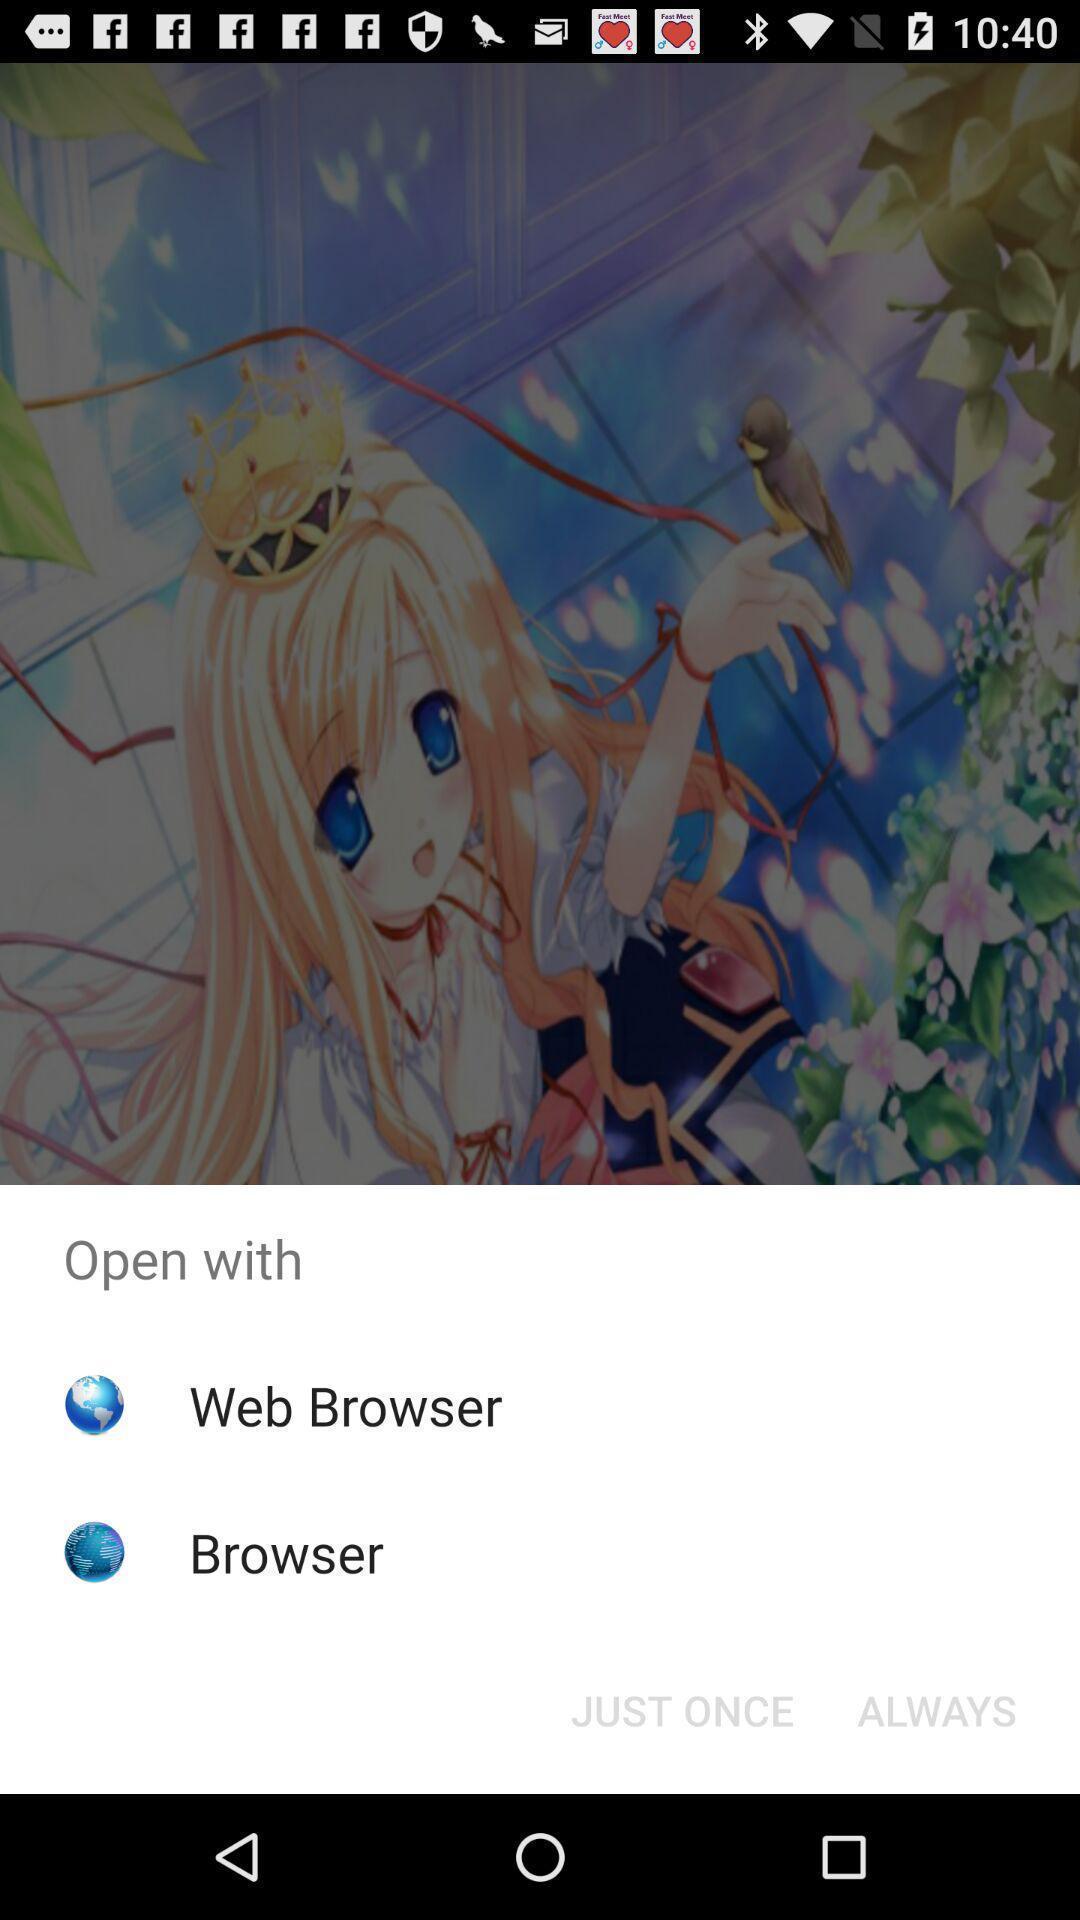Summarize the information in this screenshot. Popup to open with different browsers. 